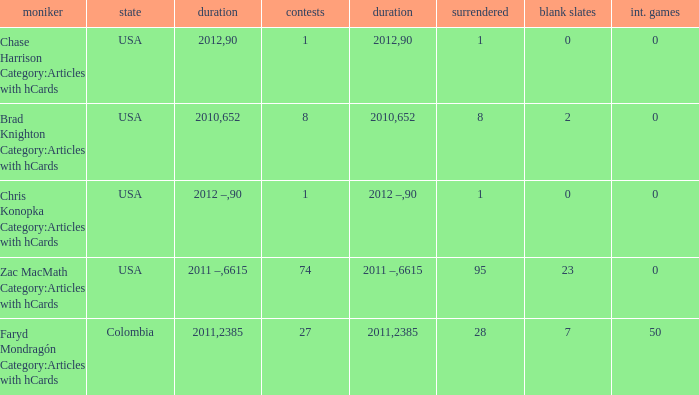What is the lowest overall amount of shutouts? 0.0. 